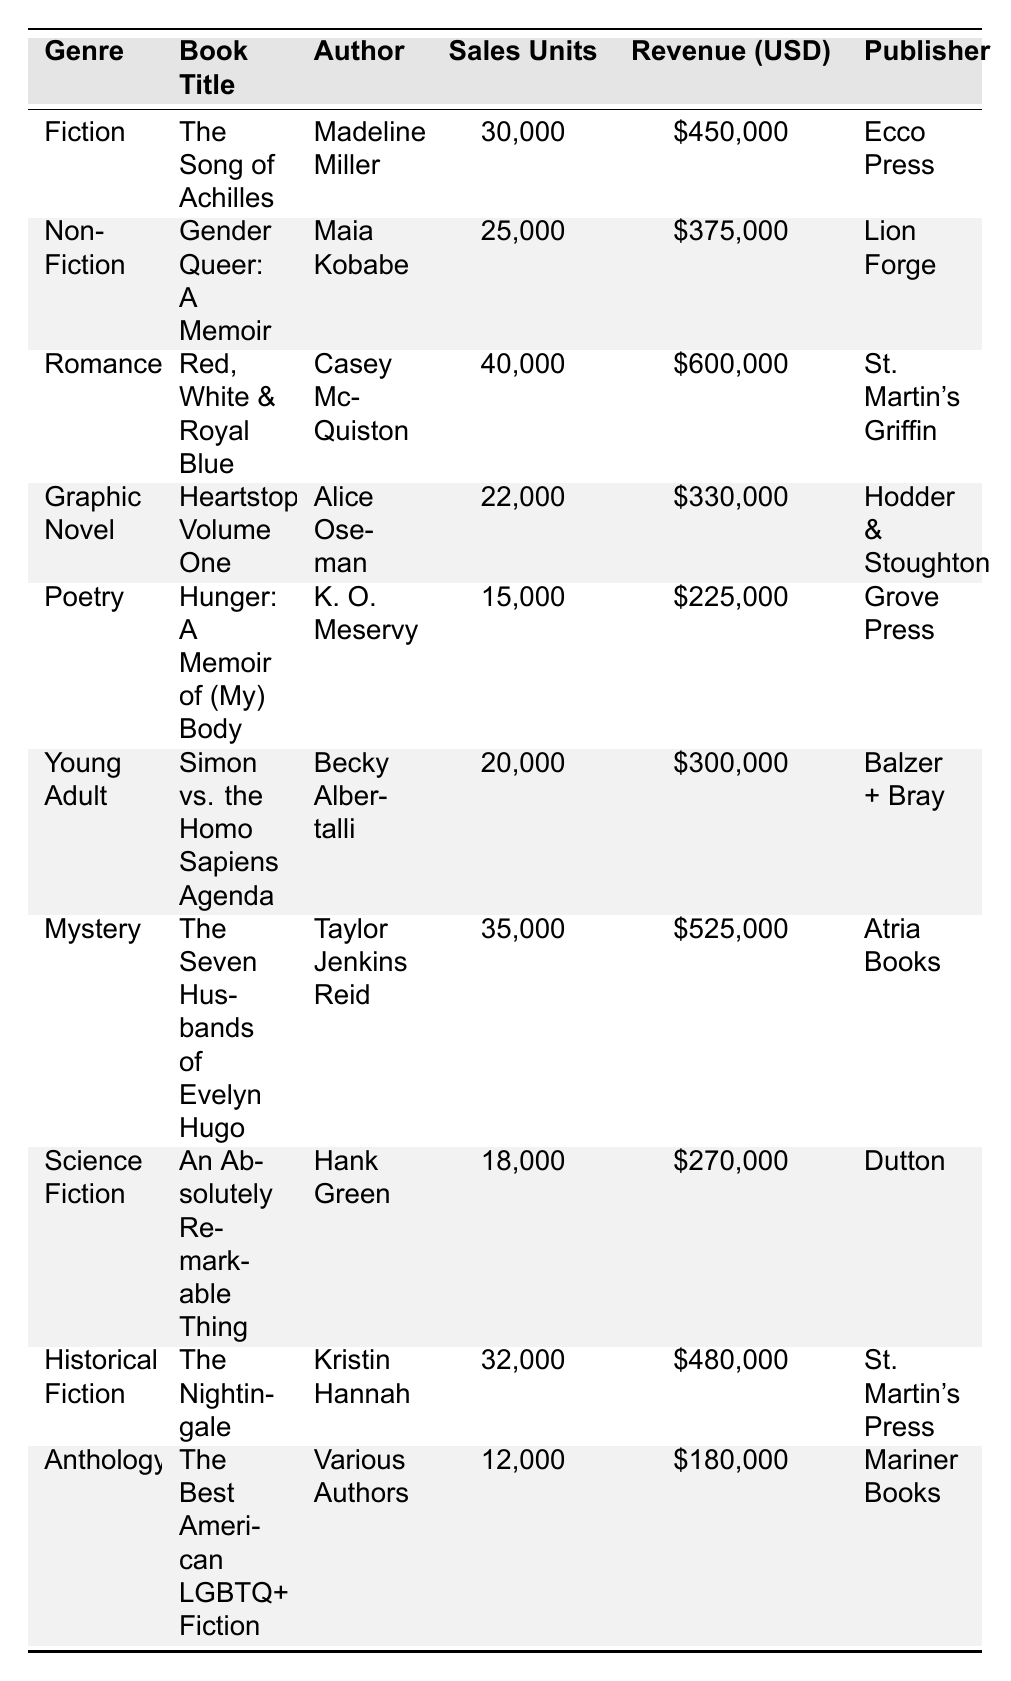What is the total number of sales units for all the books combined? To find the total sales units, we add up the sales units from all listed books: 30,000 + 25,000 + 40,000 + 22,000 + 15,000 + 20,000 + 35,000 + 18,000 + 32,000 + 12,000 =  309,000
Answer: 309,000 Which book had the highest revenue? The table indicates that "Red, White & Royal Blue" had a revenue of $600,000, which is more than the revenue for any other book listed.
Answer: Red, White & Royal Blue Is the author of "The Seven Husbands of Evelyn Hugo" the same as the author of "The Nightingale"? The author of "The Seven Husbands of Evelyn Hugo" is Taylor Jenkins Reid, while the author of "The Nightingale" is Kristin Hannah. Thus, they are different authors.
Answer: No What is the average sales units for the Poetry and Graphic Novel genres? For Poetry, the sales units are 15,000, and for Graphic Novel, they are 22,000. The average is (15,000 + 22,000) / 2 = 18,500.
Answer: 18,500 How much more revenue did the "Romance" genre generate compared to the "Fiction" genre? The revenue for "Romance" is $600,000 and for "Fiction" is $450,000. The difference in revenue is $600,000 - $450,000 = $150,000.
Answer: $150,000 Which genres had sales units below 20,000? Examining the table, "Graphic Novel" with 22,000 and "Poetry" with 15,000 are below 20,000, making "Poetry" the only genre below that threshold.
Answer: Poetry What percentage of the total sales units do the "Young Adult" books represent? The "Young Adult" category had sales of 20,000. The total sales units we calculated earlier are 309,000. Thus, the percentage is (20,000 / 309,000) * 100 ≈ 6.46%.
Answer: 6.46% What is the total revenue from all genres that are classified as non-fiction? The only non-fiction title is "Gender Queer: A Memoir," with total revenue of $375,000. Therefore, the total revenue from non-fiction genres is $375,000.
Answer: $375,000 Which genre had the least sales unit and what was it? The genre with the least sales units listed in the table is "Anthology" with 12,000 sales units.
Answer: Anthology 